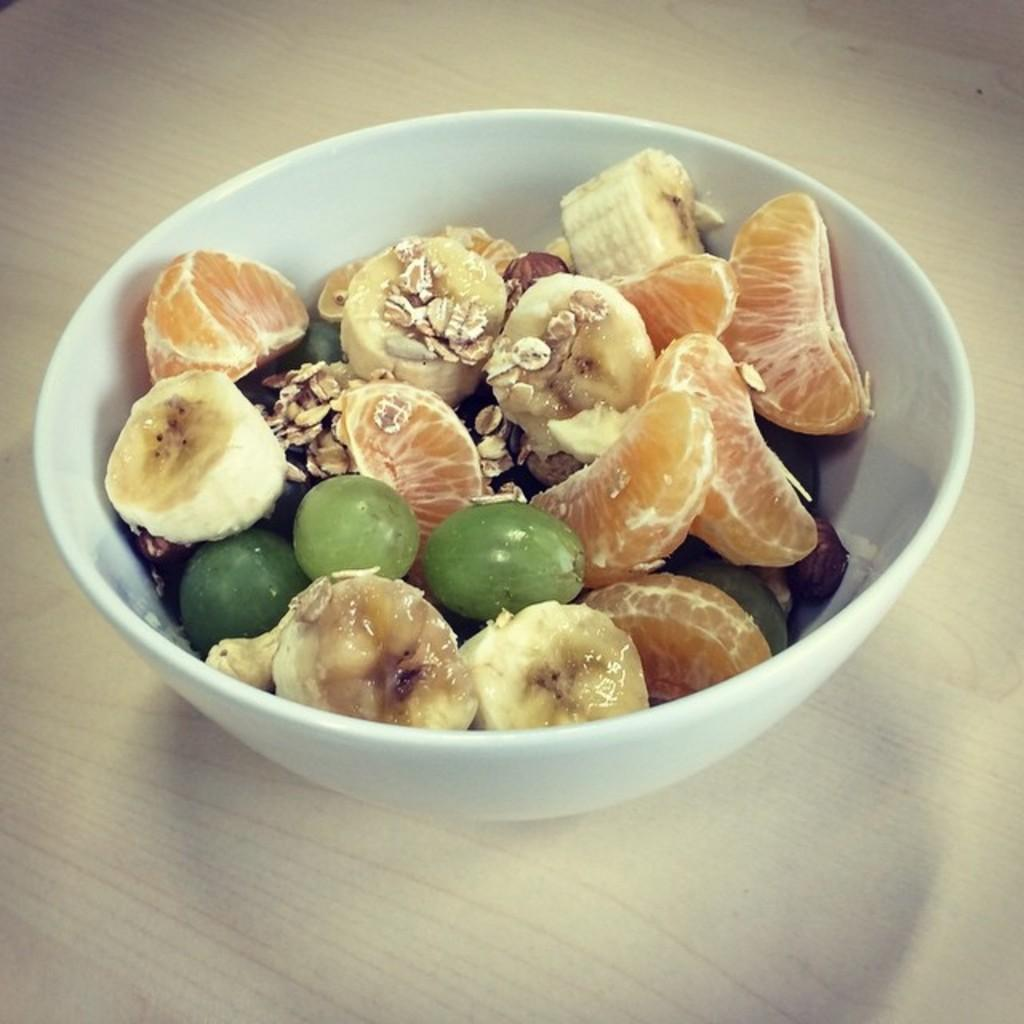What color is the bowl in the image? The bowl in the image is white. What is inside the bowl? There are fruits in the bowl. Can you name the types of fruits in the bowl? The fruits include oranges, bananas, and grapes. What type of metal is used to make the kite in the image? There is no kite present in the image, so it is not possible to determine what type of metal might be used. 